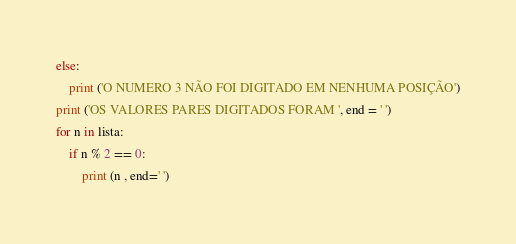Convert code to text. <code><loc_0><loc_0><loc_500><loc_500><_Python_>else:
    print ('O NUMERO 3 NÃO FOI DIGITADO EM NENHUMA POSIÇÃO')
print ('OS VALORES PARES DIGITADOS FORAM ', end = ' ')
for n in lista:
    if n % 2 == 0:
        print (n , end=' ')</code> 